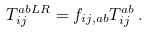Convert formula to latex. <formula><loc_0><loc_0><loc_500><loc_500>T _ { i j } ^ { a b L R } = f _ { i j , a b } T _ { i j } ^ { a b } \, .</formula> 